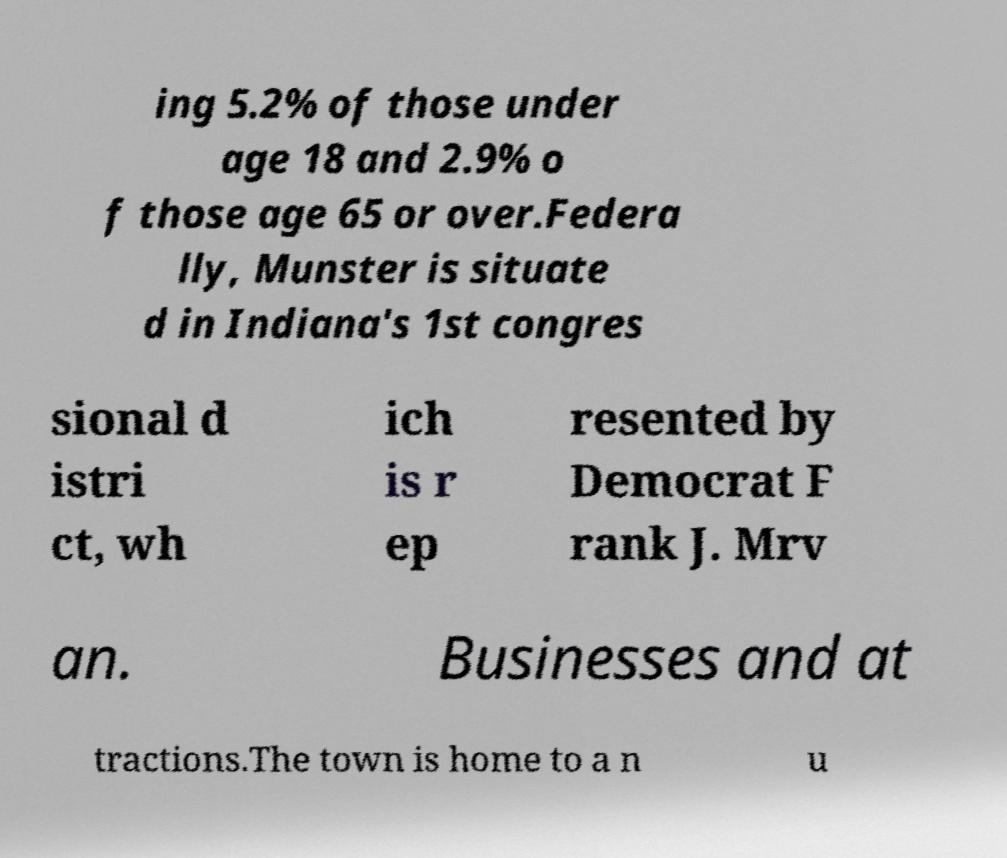Could you extract and type out the text from this image? ing 5.2% of those under age 18 and 2.9% o f those age 65 or over.Federa lly, Munster is situate d in Indiana's 1st congres sional d istri ct, wh ich is r ep resented by Democrat F rank J. Mrv an. Businesses and at tractions.The town is home to a n u 